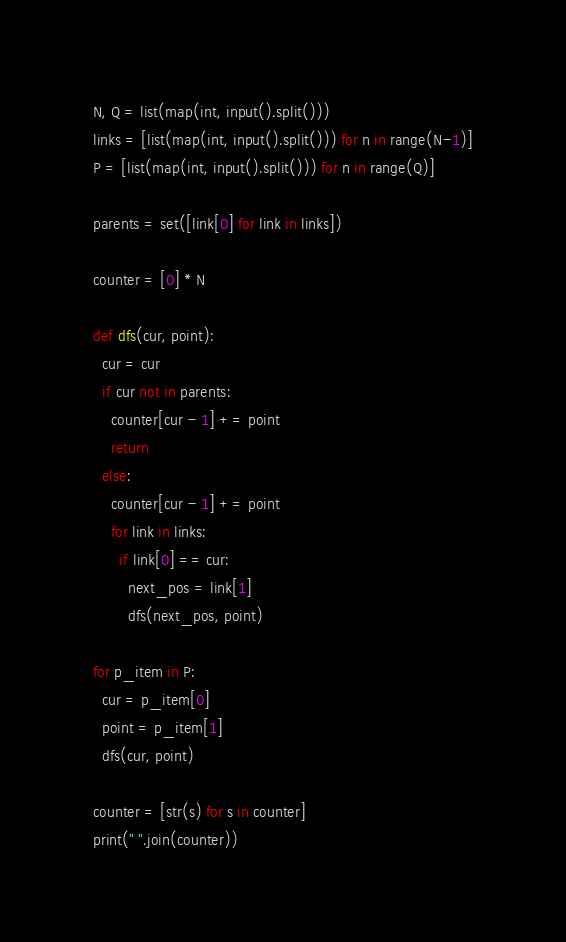Convert code to text. <code><loc_0><loc_0><loc_500><loc_500><_Python_>N, Q = list(map(int, input().split()))
links = [list(map(int, input().split())) for n in range(N-1)]
P = [list(map(int, input().split())) for n in range(Q)]

parents = set([link[0] for link in links])

counter = [0] * N

def dfs(cur, point):
  cur = cur
  if cur not in parents:
    counter[cur - 1] += point
    return
  else:
    counter[cur - 1] += point
    for link in links:
      if link[0] == cur:
        next_pos = link[1]
        dfs(next_pos, point)

for p_item in P:
  cur = p_item[0]
  point = p_item[1]
  dfs(cur, point)

counter = [str(s) for s in counter]
print(" ".join(counter))</code> 